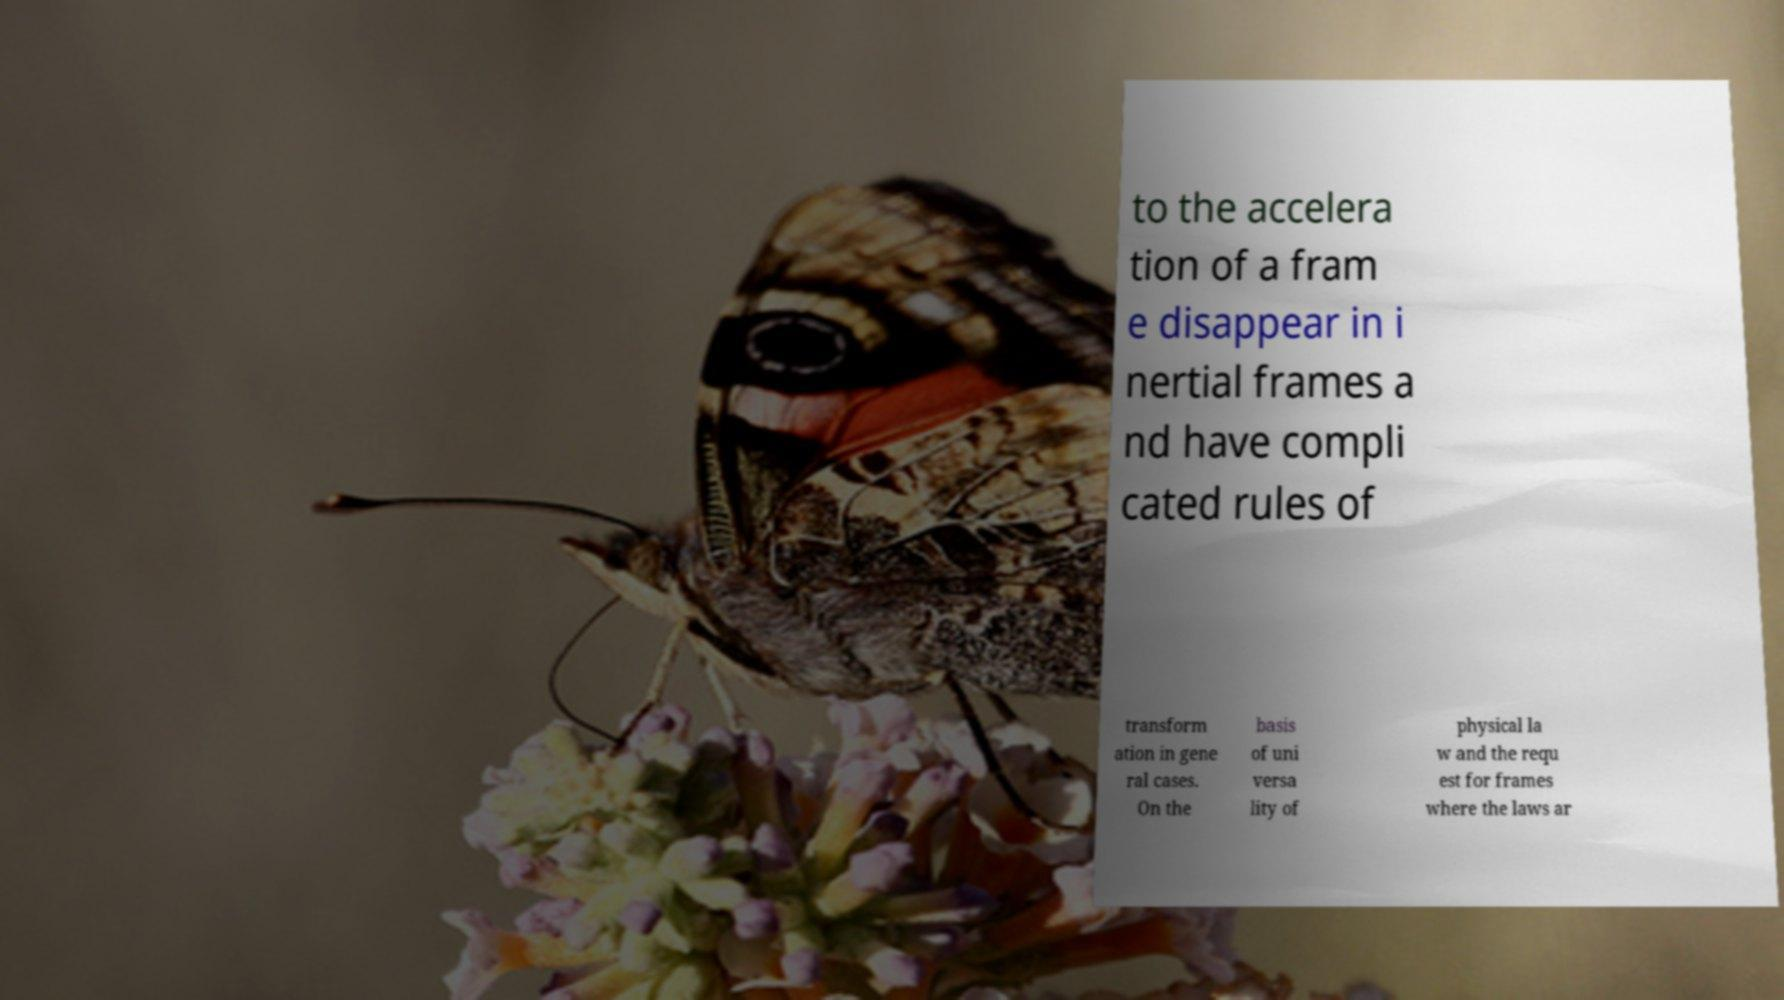Can you read and provide the text displayed in the image?This photo seems to have some interesting text. Can you extract and type it out for me? to the accelera tion of a fram e disappear in i nertial frames a nd have compli cated rules of transform ation in gene ral cases. On the basis of uni versa lity of physical la w and the requ est for frames where the laws ar 